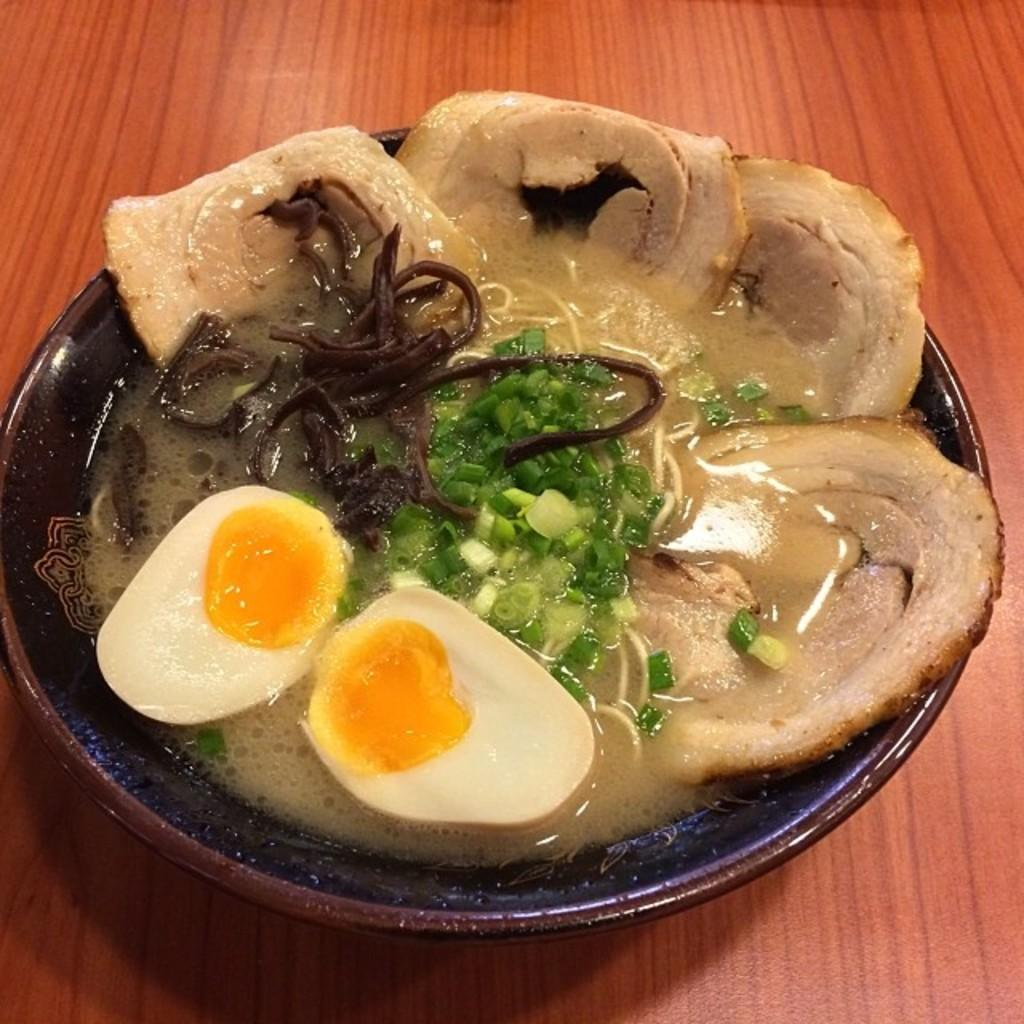What is on the plate that is visible in the image? There is food on the plate in the image. Where is the plate located in the image? The plate is placed on a table in the image. What type of roof can be seen on the plate in the image? There is no roof present on the plate in the image; it is a plate with food. How many birds are sitting on the plate in the image? There are no birds present on the plate in the image; it is a plate with food. 